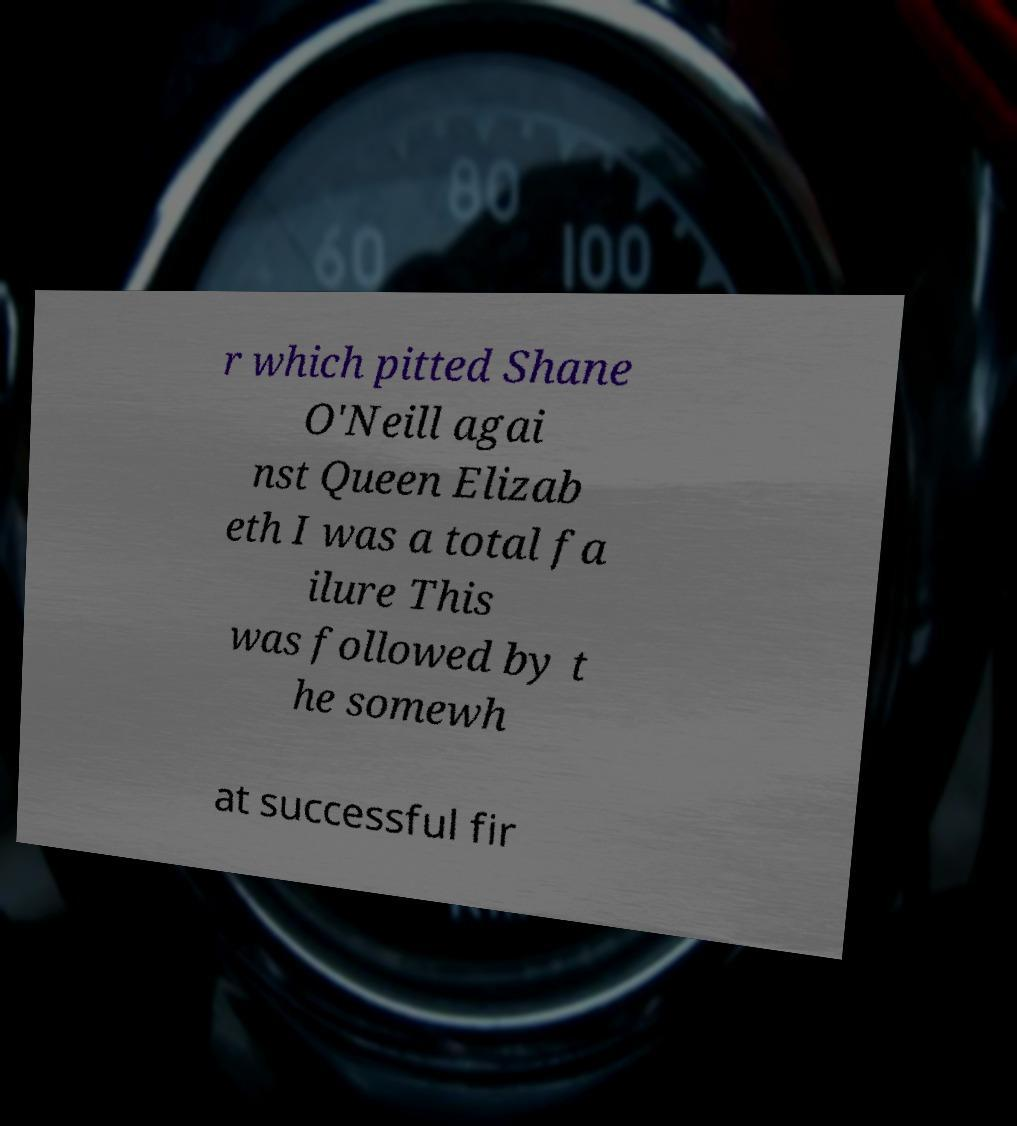Could you assist in decoding the text presented in this image and type it out clearly? r which pitted Shane O'Neill agai nst Queen Elizab eth I was a total fa ilure This was followed by t he somewh at successful fir 